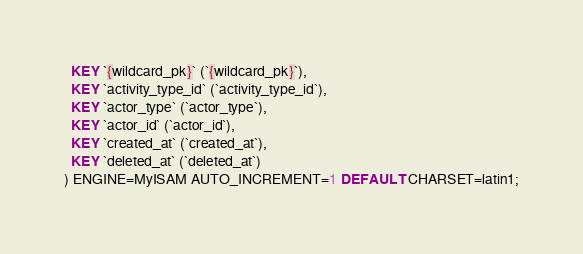Convert code to text. <code><loc_0><loc_0><loc_500><loc_500><_SQL_>  KEY `{wildcard_pk}` (`{wildcard_pk}`),
  KEY `activity_type_id` (`activity_type_id`),
  KEY `actor_type` (`actor_type`),
  KEY `actor_id` (`actor_id`),
  KEY `created_at` (`created_at`),
  KEY `deleted_at` (`deleted_at`)
) ENGINE=MyISAM AUTO_INCREMENT=1 DEFAULT CHARSET=latin1;</code> 